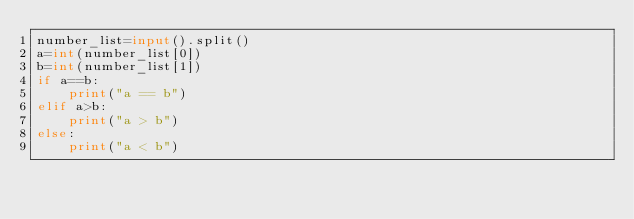Convert code to text. <code><loc_0><loc_0><loc_500><loc_500><_Python_>number_list=input().split()
a=int(number_list[0])
b=int(number_list[1])
if a==b:
    print("a == b")
elif a>b:
    print("a > b")
else:
    print("a < b")</code> 